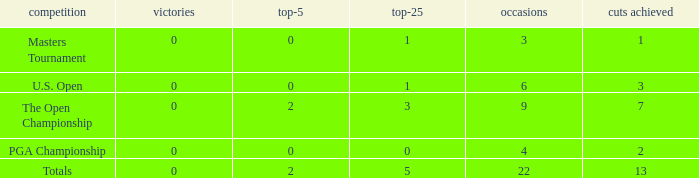What is the average number of cuts made for events with 0 top-5s? None. 